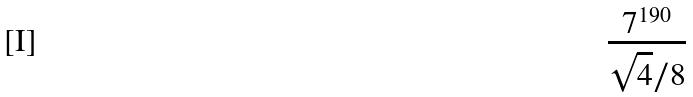Convert formula to latex. <formula><loc_0><loc_0><loc_500><loc_500>\frac { 7 ^ { 1 9 0 } } { \sqrt { 4 } / 8 }</formula> 